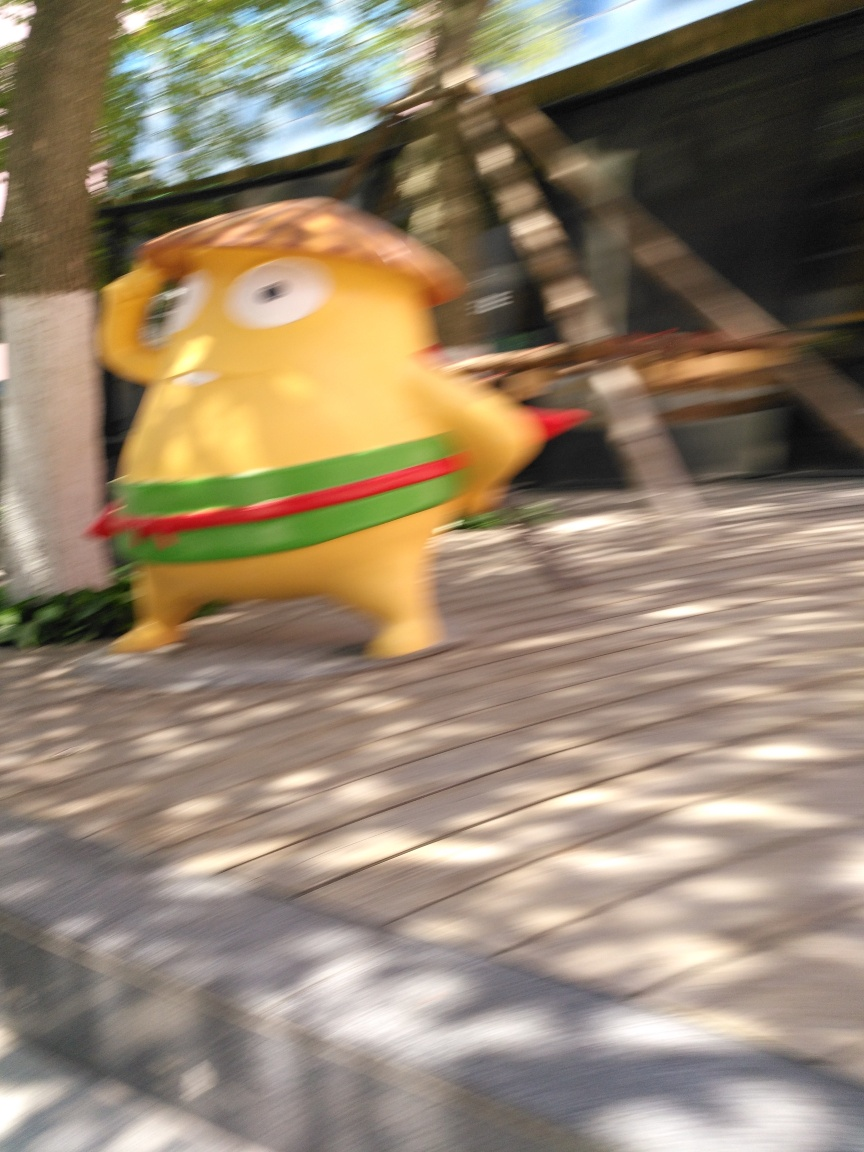If this image is part of a story, what could that story be? If this image is a narrative element, the story could revolve around a magical or fantastical character in motion, perhaps on a quest or in the midst of an adventure. The blur suggests rapid action, so the character might be hurrying to achieve an important goal or escaping from something. 